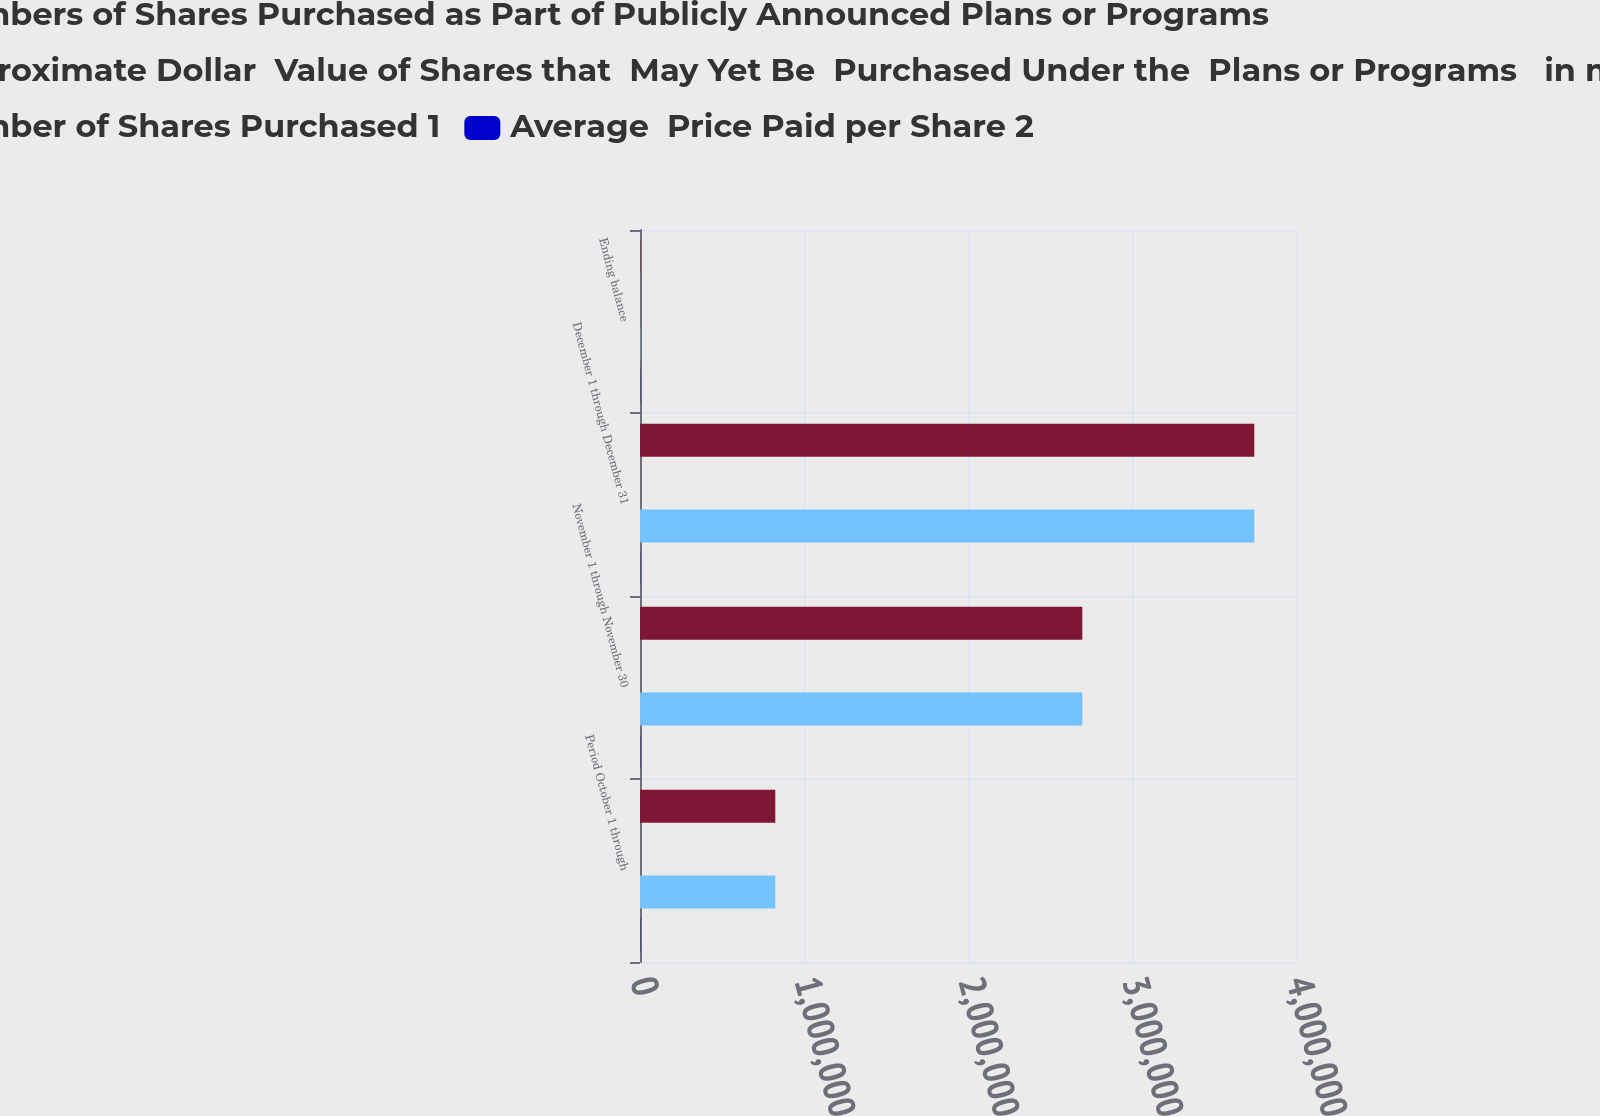Convert chart. <chart><loc_0><loc_0><loc_500><loc_500><stacked_bar_chart><ecel><fcel>Period October 1 through<fcel>November 1 through November 30<fcel>December 1 through December 31<fcel>Ending balance<nl><fcel>Numbers of Shares Purchased as Part of Publicly Announced Plans or Programs<fcel>824990<fcel>2.69703e+06<fcel>3.7458e+06<fcel>1817.5<nl><fcel>Approximate Dollar  Value of Shares that  May Yet Be  Purchased Under the  Plans or Programs   in millions<fcel>68.8<fcel>66.11<fcel>67.24<fcel>66.99<nl><fcel>Number of Shares Purchased 1<fcel>824990<fcel>2.69703e+06<fcel>3.7458e+06<fcel>1817.5<nl><fcel>Average  Price Paid per Share 2<fcel>1907<fcel>1728<fcel>1476<fcel>1476<nl></chart> 